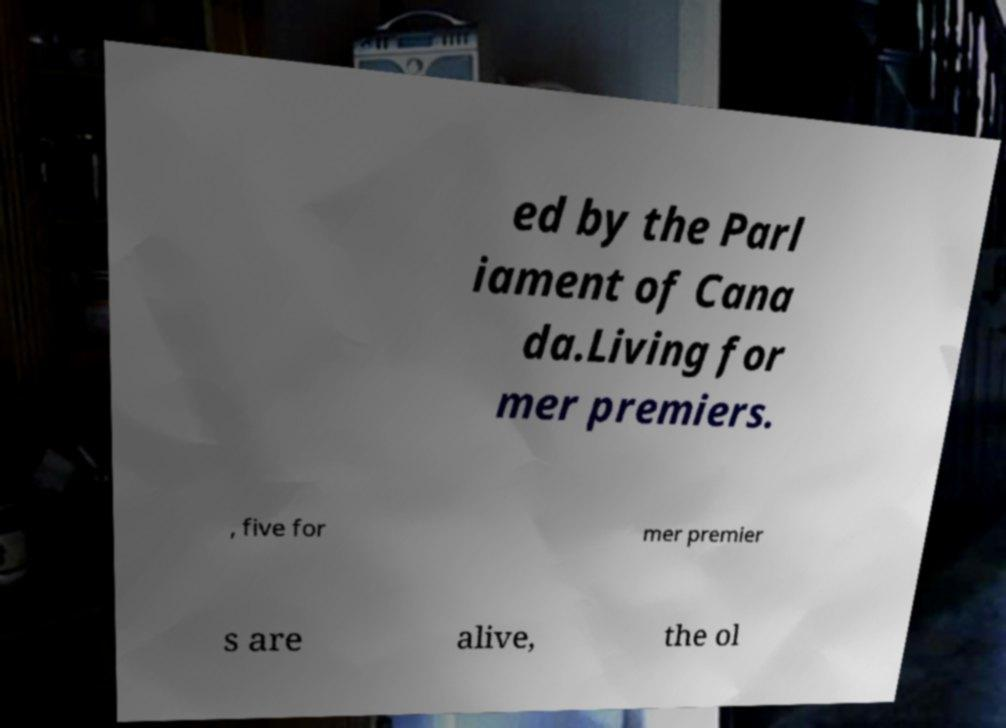I need the written content from this picture converted into text. Can you do that? ed by the Parl iament of Cana da.Living for mer premiers. , five for mer premier s are alive, the ol 